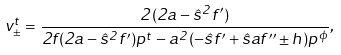Convert formula to latex. <formula><loc_0><loc_0><loc_500><loc_500>v ^ { t } _ { \pm } = \frac { 2 ( 2 a - { \hat { s } } ^ { 2 } f ^ { \prime } ) } { 2 f ( 2 a - { \hat { s } } ^ { 2 } f ^ { \prime } ) p ^ { t } - a ^ { 2 } ( - { \hat { s } } f ^ { \prime } + { \hat { s } } a f ^ { \prime \prime } \pm h ) p ^ { \phi } } ,</formula> 